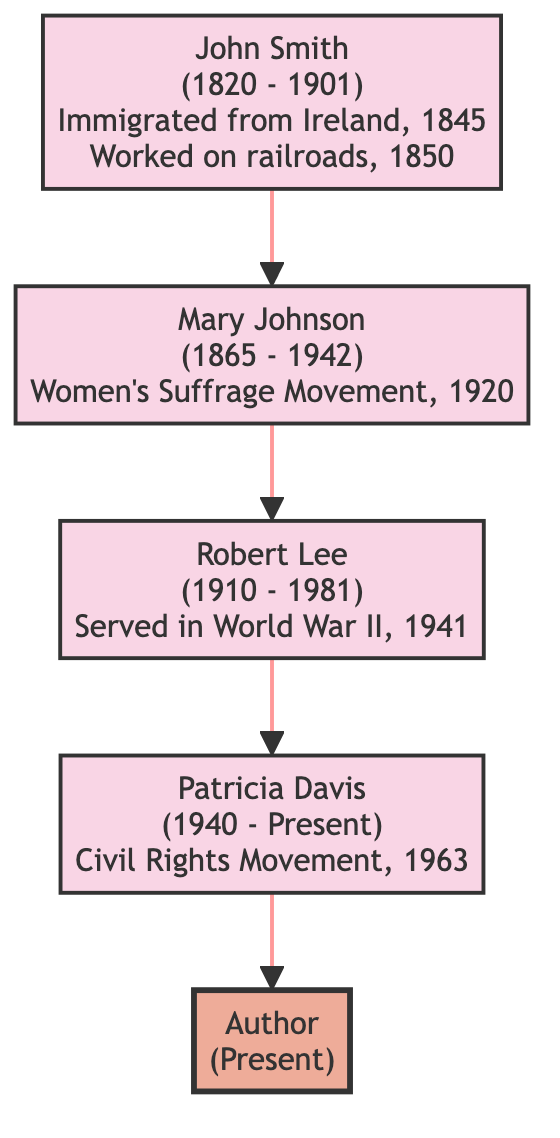What is the birth year of John Smith? The diagram displays the birth year of John Smith, and it shows "1820" next to his name.
Answer: 1820 Who was involved in the Civil Rights Movement? The diagram indicates that Patricia Davis, shown as a descendant, participated in the Civil Rights Movement, which is mentioned directly below her name.
Answer: Patricia Davis How many ancestors are shown in the diagram? By counting the distinct names listed in the diagram, there are four ancestors illustrated, namely John Smith, Mary Johnson, Robert Lee, and Patricia Davis.
Answer: 4 Which ancestor was born in 1910? The diagram presents Robert Lee's birth year as "1910," which is explicitly stated next to his name.
Answer: Robert Lee What event is associated with Mary Johnson? The diagram clearly links Mary Johnson to the Women's Suffrage Movement, indicated in her event description.
Answer: Women's Suffrage Movement Who is the parent of Robert Lee? The diagram shows an arrow connecting Mary Johnson to Robert Lee, indicating that Mary is the parent of Robert.
Answer: Mary Johnson What historical context is connected to Patricia Davis? The diagram outlines Patricia Davis’s involvement in the Civil Rights Movement, which occurred amid the context of the March on Washington in 1963.
Answer: March on Washington What type of tree structure is used in the diagram? The diagram is a family tree structure that illustrates generational relationships between ancestors and the author.
Answer: Family tree Which ancestor's experience is described as shaping the author's understanding of courage? The text adjacent to Robert Lee highlights his experiences in World War II, describing how those experiences shaped the author's understanding of courage.
Answer: Robert Lee 